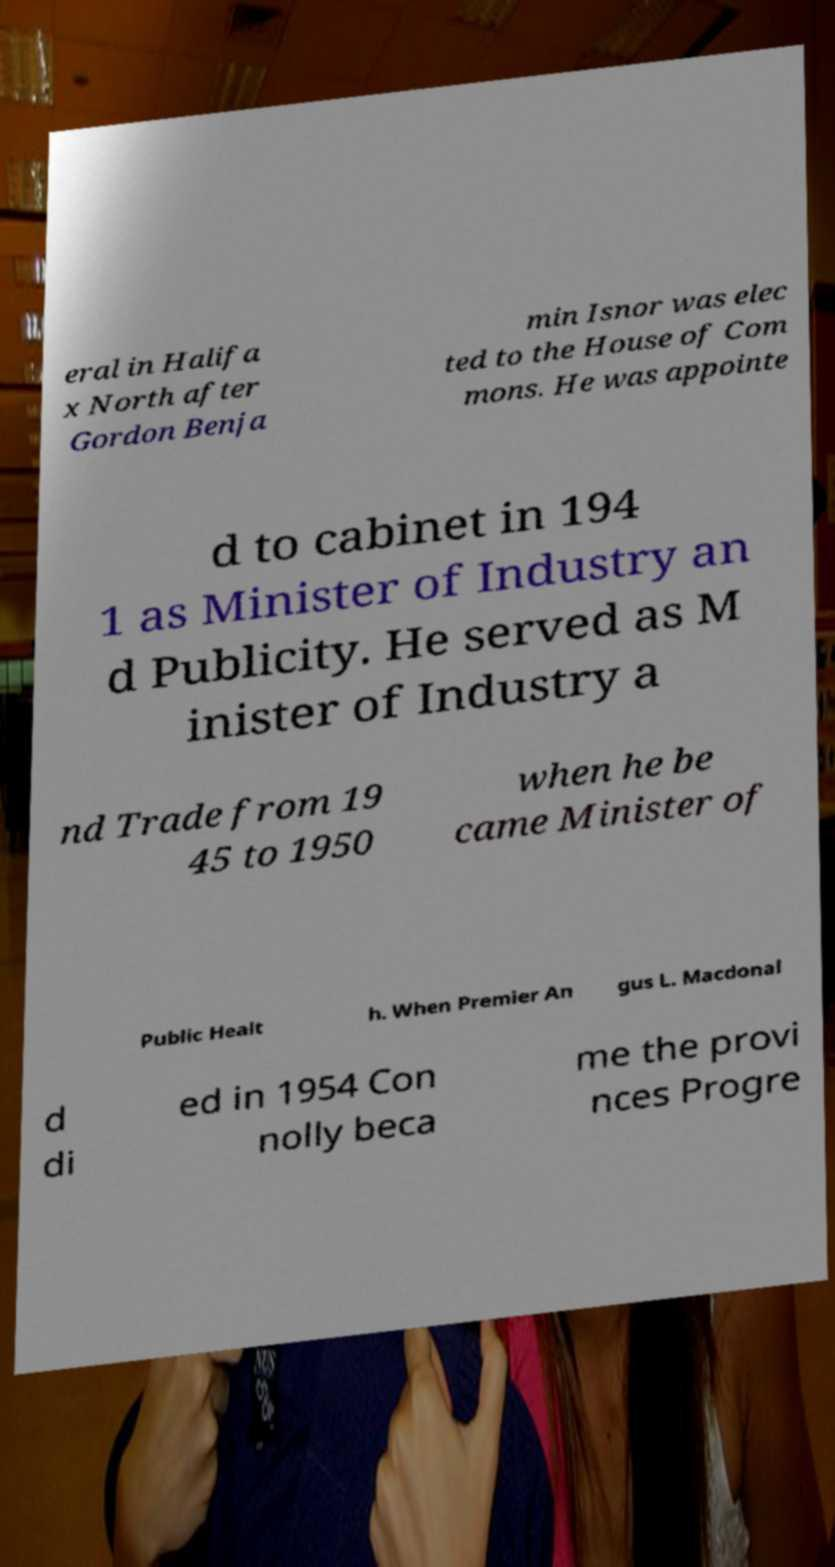Can you read and provide the text displayed in the image?This photo seems to have some interesting text. Can you extract and type it out for me? eral in Halifa x North after Gordon Benja min Isnor was elec ted to the House of Com mons. He was appointe d to cabinet in 194 1 as Minister of Industry an d Publicity. He served as M inister of Industry a nd Trade from 19 45 to 1950 when he be came Minister of Public Healt h. When Premier An gus L. Macdonal d di ed in 1954 Con nolly beca me the provi nces Progre 